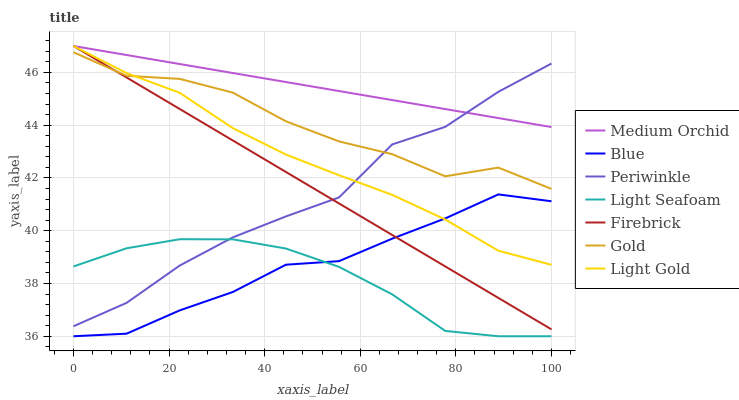Does Light Seafoam have the minimum area under the curve?
Answer yes or no. Yes. Does Medium Orchid have the maximum area under the curve?
Answer yes or no. Yes. Does Gold have the minimum area under the curve?
Answer yes or no. No. Does Gold have the maximum area under the curve?
Answer yes or no. No. Is Medium Orchid the smoothest?
Answer yes or no. Yes. Is Gold the roughest?
Answer yes or no. Yes. Is Firebrick the smoothest?
Answer yes or no. No. Is Firebrick the roughest?
Answer yes or no. No. Does Gold have the lowest value?
Answer yes or no. No. Does Gold have the highest value?
Answer yes or no. No. Is Blue less than Gold?
Answer yes or no. Yes. Is Gold greater than Light Seafoam?
Answer yes or no. Yes. Does Blue intersect Gold?
Answer yes or no. No. 